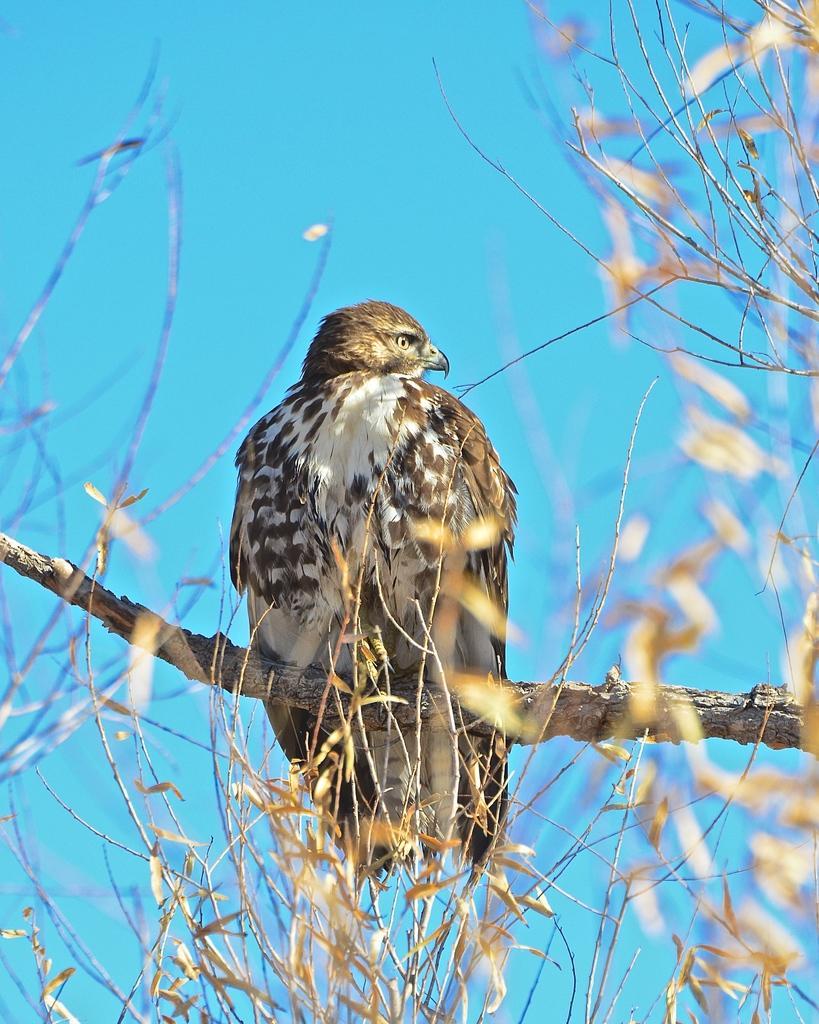Could you give a brief overview of what you see in this image? In this image we can see there is a bird on the tree. In the background there is a sky. 